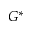<formula> <loc_0><loc_0><loc_500><loc_500>G ^ { * }</formula> 